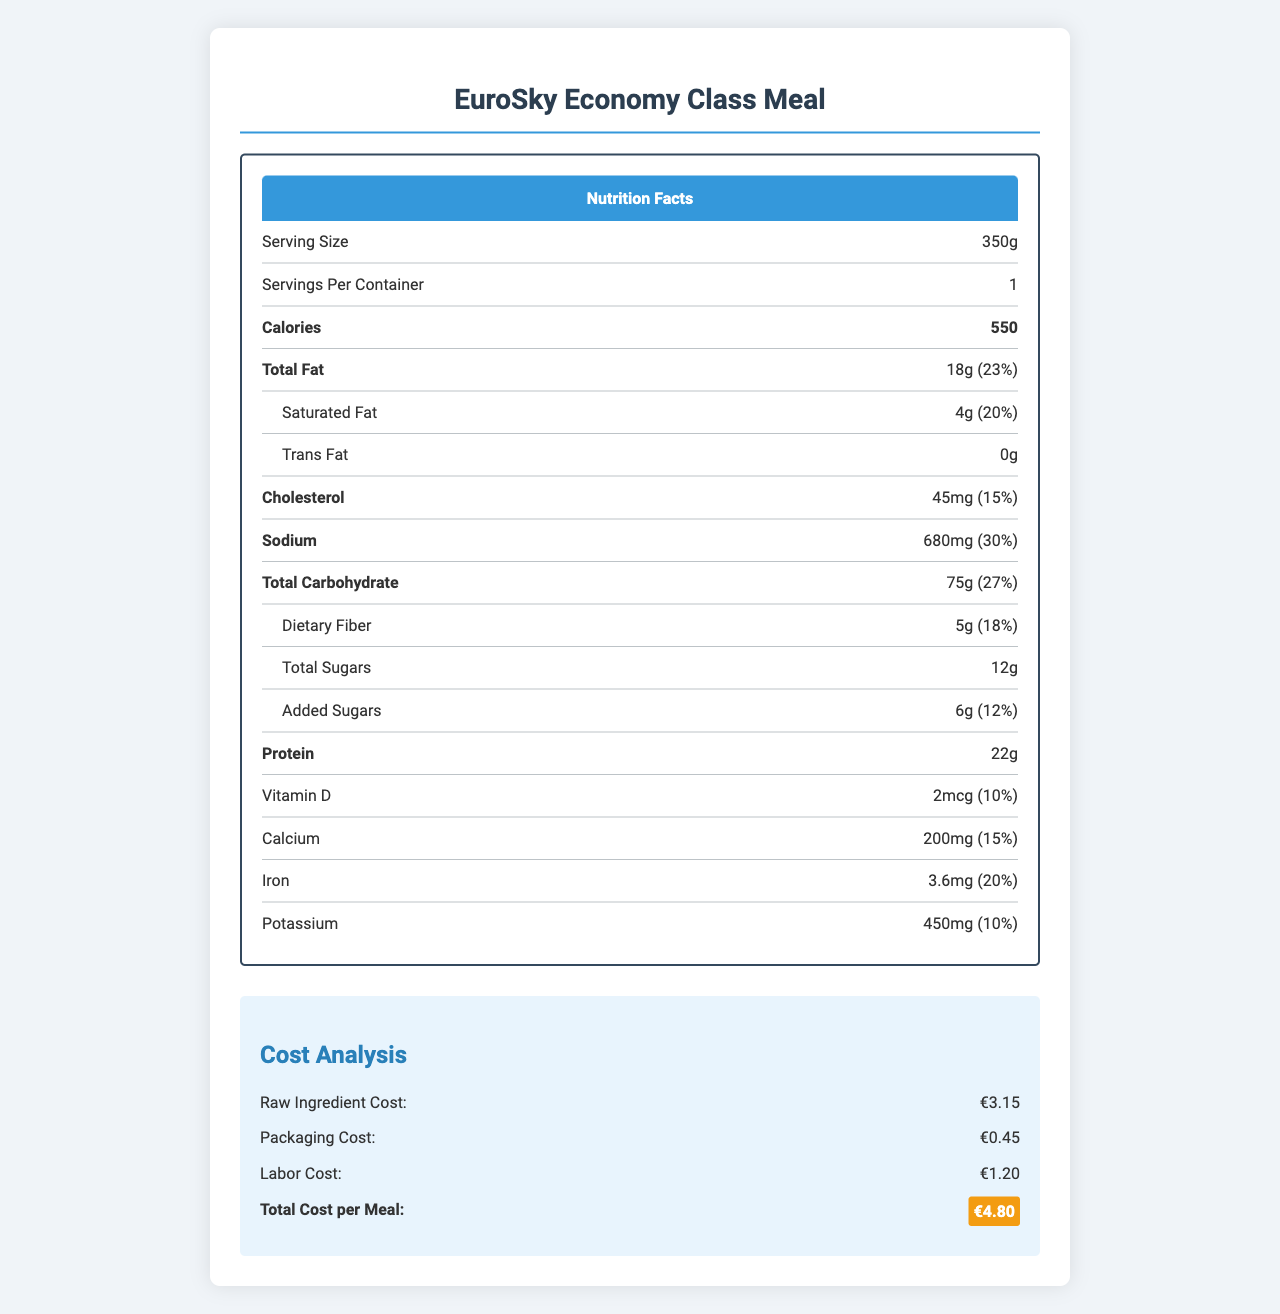what is the serving size of the EuroSky Economy Class Meal? The serving size is explicitly stated as "350g" in the nutritional information section of the document.
Answer: 350g how much total fat does the meal contain? The document lists "Total Fat" under the nutrition facts, showing an amount of "18g".
Answer: 18g what is the total cost per meal for the EuroSky Economy Class Meal? In the "Cost Analysis" section, the "Total Cost per Meal" is highlighted as "€4.80".
Answer: €4.80 how many grams of protein are present in the meal? The nutrition label details "Protein" as having an amount of "22g".
Answer: 22g what is the sodium content percentage of daily value in this meal? The nutrition label indicates the sodium content and its daily value percentage as "30%".
Answer: 30% how much does raw ingredient cost per meal? Under the "Cost Analysis" section, "Raw Ingredient Cost" is stated as "€3.15".
Answer: €3.15 which of the following benefits are highlighted as part of the nutritional highlights? A. High Sugar Content B. Low Sodium C. No Fiber D. No Added Sugars The document highlights "low sodium" among the nutritional highlights.
Answer: B what guidelines and regulations does the meal comply with? A. EC 1169/2011 and IATA B. FDA and WHO C. USDA and CAA D. EU 212/2021 and WHO The document mentions compliance with "EC 1169/2011 on food information to consumers" and "IATA guidelines for airline catering".
Answer: A does the document mention any allergen information? The document lists "Contains wheat, milk, and soy" under regulatory compliance, indicating allergen information.
Answer: Yes describe the main idea of the document The document contains various sections including Nutrition Facts, Cost Analysis, Economic Considerations, Nutritional Highlights, Regulatory Compliance, and Sustainability Efforts. It provides comprehensive data regarding the meal's nutritional content, cost structure, compliance with regulations, and sustainability practices.
Answer: The document presents detailed nutritional information, cost analysis, and economic considerations for the EuroSky Economy Class Meal, while highlighting its nutritional benefits, regulatory compliance, and sustainability efforts. what is the exact source of the packaging materials for the meal? The document mentions that the packaging is "Recyclable and compostable materials" but does not provide the exact source of these materials.
Answer: Not enough information 